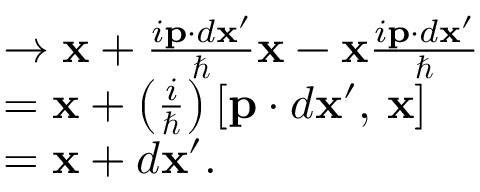<formula> <loc_0><loc_0><loc_500><loc_500>\begin{array} { r l } & { \to \mathbf x + \frac { i \mathbf p \cdot d x ^ { \prime } } { } \mathbf x - \mathbf x \frac { i \mathbf p \cdot d x ^ { \prime } } { } } \\ & { = \mathbf x + \left ( \frac { i } { } \right ) \left [ \mathbf p \cdot d \mathbf x ^ { \prime } , \, \mathbf x \right ] } \\ & { = \mathbf x + d \mathbf x ^ { \prime } . } \end{array}</formula> 